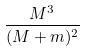<formula> <loc_0><loc_0><loc_500><loc_500>\frac { M ^ { 3 } } { ( M + m ) ^ { 2 } }</formula> 